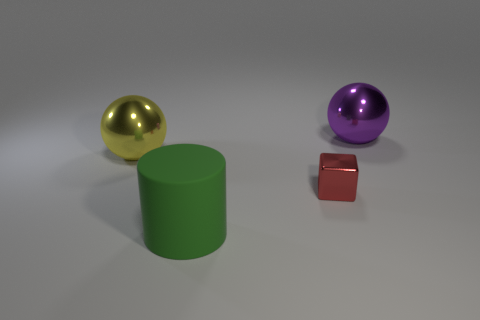Add 1 big shiny blocks. How many objects exist? 5 Subtract 1 green cylinders. How many objects are left? 3 Subtract all matte cylinders. Subtract all blue matte cubes. How many objects are left? 3 Add 3 red metallic cubes. How many red metallic cubes are left? 4 Add 2 blocks. How many blocks exist? 3 